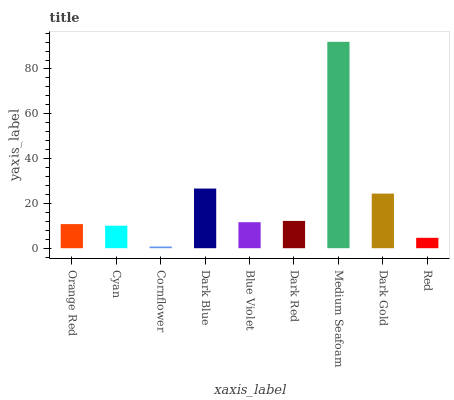Is Cyan the minimum?
Answer yes or no. No. Is Cyan the maximum?
Answer yes or no. No. Is Orange Red greater than Cyan?
Answer yes or no. Yes. Is Cyan less than Orange Red?
Answer yes or no. Yes. Is Cyan greater than Orange Red?
Answer yes or no. No. Is Orange Red less than Cyan?
Answer yes or no. No. Is Blue Violet the high median?
Answer yes or no. Yes. Is Blue Violet the low median?
Answer yes or no. Yes. Is Dark Red the high median?
Answer yes or no. No. Is Cornflower the low median?
Answer yes or no. No. 